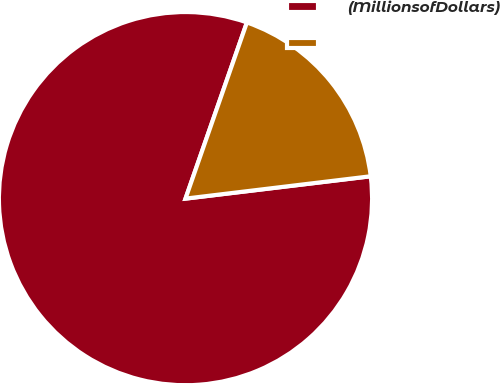Convert chart to OTSL. <chart><loc_0><loc_0><loc_500><loc_500><pie_chart><fcel>(MillionsofDollars)<fcel>Unnamed: 1<nl><fcel>82.25%<fcel>17.75%<nl></chart> 